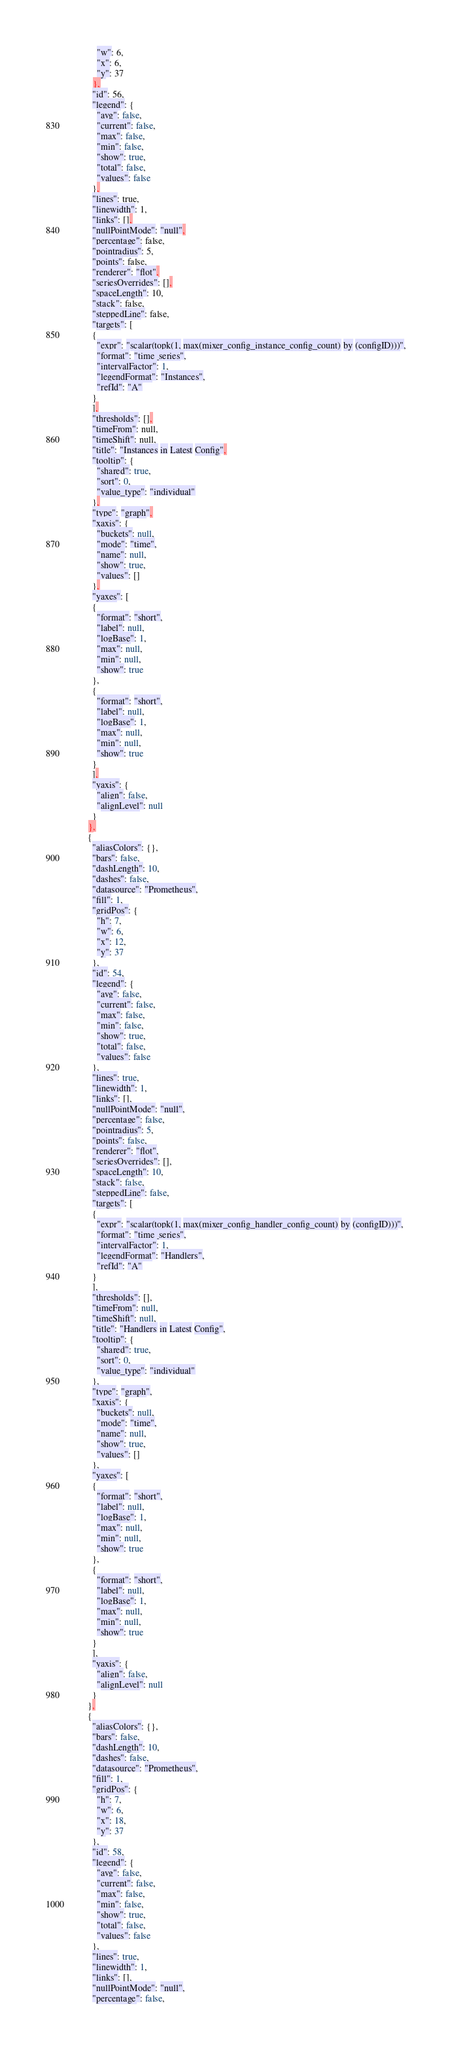Convert code to text. <code><loc_0><loc_0><loc_500><loc_500><_YAML_>          "w": 6,
          "x": 6,
          "y": 37
        },
        "id": 56,
        "legend": {
          "avg": false,
          "current": false,
          "max": false,
          "min": false,
          "show": true,
          "total": false,
          "values": false
        },
        "lines": true,
        "linewidth": 1,
        "links": [],
        "nullPointMode": "null",
        "percentage": false,
        "pointradius": 5,
        "points": false,
        "renderer": "flot",
        "seriesOverrides": [],
        "spaceLength": 10,
        "stack": false,
        "steppedLine": false,
        "targets": [
        {
          "expr": "scalar(topk(1, max(mixer_config_instance_config_count) by (configID)))",
          "format": "time_series",
          "intervalFactor": 1,
          "legendFormat": "Instances",
          "refId": "A"
        }
        ],
        "thresholds": [],
        "timeFrom": null,
        "timeShift": null,
        "title": "Instances in Latest Config",
        "tooltip": {
          "shared": true,
          "sort": 0,
          "value_type": "individual"
        },
        "type": "graph",
        "xaxis": {
          "buckets": null,
          "mode": "time",
          "name": null,
          "show": true,
          "values": []
        },
        "yaxes": [
        {
          "format": "short",
          "label": null,
          "logBase": 1,
          "max": null,
          "min": null,
          "show": true
        },
        {
          "format": "short",
          "label": null,
          "logBase": 1,
          "max": null,
          "min": null,
          "show": true
        }
        ],
        "yaxis": {
          "align": false,
          "alignLevel": null
        }
      },
      {
        "aliasColors": {},
        "bars": false,
        "dashLength": 10,
        "dashes": false,
        "datasource": "Prometheus",
        "fill": 1,
        "gridPos": {
          "h": 7,
          "w": 6,
          "x": 12,
          "y": 37
        },
        "id": 54,
        "legend": {
          "avg": false,
          "current": false,
          "max": false,
          "min": false,
          "show": true,
          "total": false,
          "values": false
        },
        "lines": true,
        "linewidth": 1,
        "links": [],
        "nullPointMode": "null",
        "percentage": false,
        "pointradius": 5,
        "points": false,
        "renderer": "flot",
        "seriesOverrides": [],
        "spaceLength": 10,
        "stack": false,
        "steppedLine": false,
        "targets": [
        {
          "expr": "scalar(topk(1, max(mixer_config_handler_config_count) by (configID)))",
          "format": "time_series",
          "intervalFactor": 1,
          "legendFormat": "Handlers",
          "refId": "A"
        }
        ],
        "thresholds": [],
        "timeFrom": null,
        "timeShift": null,
        "title": "Handlers in Latest Config",
        "tooltip": {
          "shared": true,
          "sort": 0,
          "value_type": "individual"
        },
        "type": "graph",
        "xaxis": {
          "buckets": null,
          "mode": "time",
          "name": null,
          "show": true,
          "values": []
        },
        "yaxes": [
        {
          "format": "short",
          "label": null,
          "logBase": 1,
          "max": null,
          "min": null,
          "show": true
        },
        {
          "format": "short",
          "label": null,
          "logBase": 1,
          "max": null,
          "min": null,
          "show": true
        }
        ],
        "yaxis": {
          "align": false,
          "alignLevel": null
        }
      },
      {
        "aliasColors": {},
        "bars": false,
        "dashLength": 10,
        "dashes": false,
        "datasource": "Prometheus",
        "fill": 1,
        "gridPos": {
          "h": 7,
          "w": 6,
          "x": 18,
          "y": 37
        },
        "id": 58,
        "legend": {
          "avg": false,
          "current": false,
          "max": false,
          "min": false,
          "show": true,
          "total": false,
          "values": false
        },
        "lines": true,
        "linewidth": 1,
        "links": [],
        "nullPointMode": "null",
        "percentage": false,</code> 